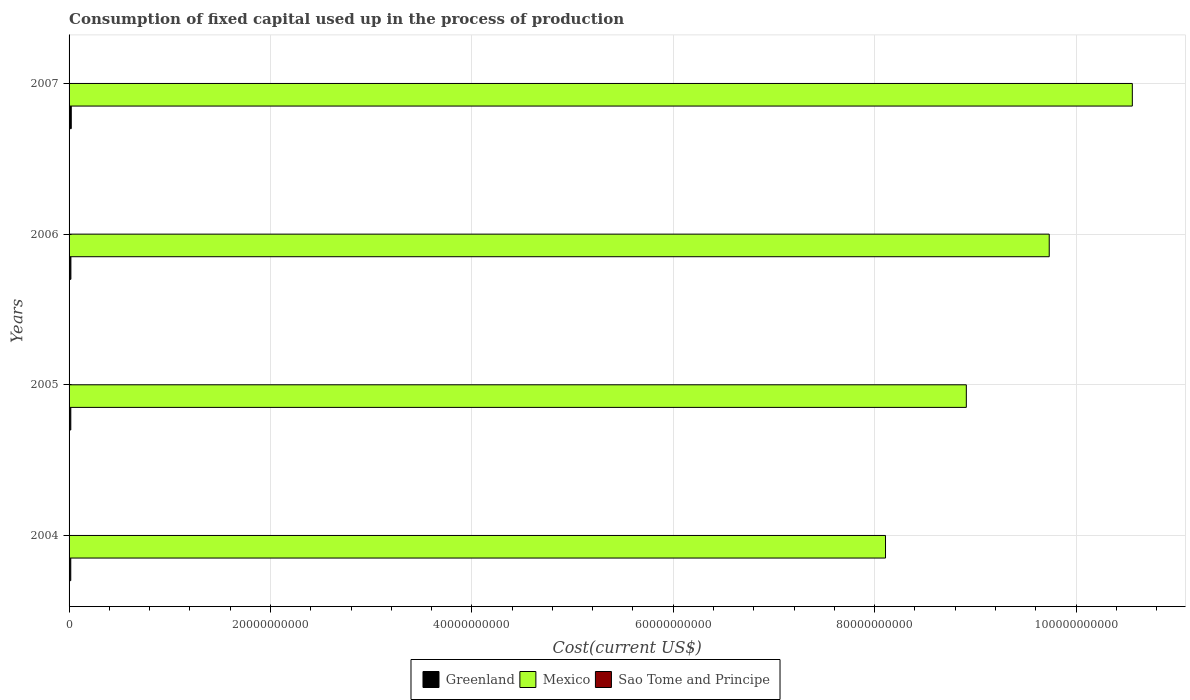How many bars are there on the 2nd tick from the bottom?
Offer a very short reply. 3. What is the amount consumed in the process of production in Sao Tome and Principe in 2004?
Your answer should be compact. 1.56e+07. Across all years, what is the maximum amount consumed in the process of production in Greenland?
Your answer should be compact. 2.18e+08. Across all years, what is the minimum amount consumed in the process of production in Mexico?
Provide a short and direct response. 8.11e+1. What is the total amount consumed in the process of production in Greenland in the graph?
Provide a short and direct response. 7.39e+08. What is the difference between the amount consumed in the process of production in Greenland in 2004 and that in 2005?
Your response must be concise. -3.38e+06. What is the difference between the amount consumed in the process of production in Sao Tome and Principe in 2006 and the amount consumed in the process of production in Mexico in 2007?
Give a very brief answer. -1.06e+11. What is the average amount consumed in the process of production in Greenland per year?
Your response must be concise. 1.85e+08. In the year 2007, what is the difference between the amount consumed in the process of production in Mexico and amount consumed in the process of production in Greenland?
Make the answer very short. 1.05e+11. What is the ratio of the amount consumed in the process of production in Mexico in 2004 to that in 2005?
Offer a terse response. 0.91. Is the amount consumed in the process of production in Mexico in 2004 less than that in 2006?
Your answer should be compact. Yes. Is the difference between the amount consumed in the process of production in Mexico in 2004 and 2005 greater than the difference between the amount consumed in the process of production in Greenland in 2004 and 2005?
Your answer should be very brief. No. What is the difference between the highest and the second highest amount consumed in the process of production in Greenland?
Your answer should be compact. 3.79e+07. What is the difference between the highest and the lowest amount consumed in the process of production in Greenland?
Give a very brief answer. 4.94e+07. What does the 3rd bar from the bottom in 2006 represents?
Your response must be concise. Sao Tome and Principe. Are all the bars in the graph horizontal?
Provide a succinct answer. Yes. What is the difference between two consecutive major ticks on the X-axis?
Give a very brief answer. 2.00e+1. Are the values on the major ticks of X-axis written in scientific E-notation?
Your response must be concise. No. Does the graph contain grids?
Provide a succinct answer. Yes. What is the title of the graph?
Ensure brevity in your answer.  Consumption of fixed capital used up in the process of production. What is the label or title of the X-axis?
Provide a succinct answer. Cost(current US$). What is the Cost(current US$) of Greenland in 2004?
Keep it short and to the point. 1.69e+08. What is the Cost(current US$) of Mexico in 2004?
Offer a very short reply. 8.11e+1. What is the Cost(current US$) in Sao Tome and Principe in 2004?
Make the answer very short. 1.56e+07. What is the Cost(current US$) in Greenland in 2005?
Provide a short and direct response. 1.72e+08. What is the Cost(current US$) in Mexico in 2005?
Your answer should be very brief. 8.91e+1. What is the Cost(current US$) of Sao Tome and Principe in 2005?
Your answer should be compact. 1.66e+07. What is the Cost(current US$) of Greenland in 2006?
Keep it short and to the point. 1.80e+08. What is the Cost(current US$) of Mexico in 2006?
Give a very brief answer. 9.73e+1. What is the Cost(current US$) of Sao Tome and Principe in 2006?
Ensure brevity in your answer.  1.69e+07. What is the Cost(current US$) in Greenland in 2007?
Provide a short and direct response. 2.18e+08. What is the Cost(current US$) in Mexico in 2007?
Keep it short and to the point. 1.06e+11. What is the Cost(current US$) in Sao Tome and Principe in 2007?
Give a very brief answer. 1.85e+07. Across all years, what is the maximum Cost(current US$) of Greenland?
Your answer should be compact. 2.18e+08. Across all years, what is the maximum Cost(current US$) in Mexico?
Provide a succinct answer. 1.06e+11. Across all years, what is the maximum Cost(current US$) in Sao Tome and Principe?
Give a very brief answer. 1.85e+07. Across all years, what is the minimum Cost(current US$) in Greenland?
Provide a succinct answer. 1.69e+08. Across all years, what is the minimum Cost(current US$) in Mexico?
Ensure brevity in your answer.  8.11e+1. Across all years, what is the minimum Cost(current US$) in Sao Tome and Principe?
Your answer should be very brief. 1.56e+07. What is the total Cost(current US$) in Greenland in the graph?
Provide a succinct answer. 7.39e+08. What is the total Cost(current US$) in Mexico in the graph?
Ensure brevity in your answer.  3.73e+11. What is the total Cost(current US$) of Sao Tome and Principe in the graph?
Offer a very short reply. 6.76e+07. What is the difference between the Cost(current US$) in Greenland in 2004 and that in 2005?
Your response must be concise. -3.38e+06. What is the difference between the Cost(current US$) in Mexico in 2004 and that in 2005?
Provide a short and direct response. -8.03e+09. What is the difference between the Cost(current US$) in Sao Tome and Principe in 2004 and that in 2005?
Make the answer very short. -1.04e+06. What is the difference between the Cost(current US$) of Greenland in 2004 and that in 2006?
Make the answer very short. -1.14e+07. What is the difference between the Cost(current US$) in Mexico in 2004 and that in 2006?
Your response must be concise. -1.63e+1. What is the difference between the Cost(current US$) of Sao Tome and Principe in 2004 and that in 2006?
Offer a very short reply. -1.29e+06. What is the difference between the Cost(current US$) in Greenland in 2004 and that in 2007?
Keep it short and to the point. -4.94e+07. What is the difference between the Cost(current US$) of Mexico in 2004 and that in 2007?
Ensure brevity in your answer.  -2.45e+1. What is the difference between the Cost(current US$) of Sao Tome and Principe in 2004 and that in 2007?
Your answer should be very brief. -2.95e+06. What is the difference between the Cost(current US$) in Greenland in 2005 and that in 2006?
Provide a succinct answer. -8.03e+06. What is the difference between the Cost(current US$) in Mexico in 2005 and that in 2006?
Ensure brevity in your answer.  -8.23e+09. What is the difference between the Cost(current US$) in Sao Tome and Principe in 2005 and that in 2006?
Your response must be concise. -2.56e+05. What is the difference between the Cost(current US$) of Greenland in 2005 and that in 2007?
Make the answer very short. -4.60e+07. What is the difference between the Cost(current US$) in Mexico in 2005 and that in 2007?
Your response must be concise. -1.65e+1. What is the difference between the Cost(current US$) of Sao Tome and Principe in 2005 and that in 2007?
Ensure brevity in your answer.  -1.92e+06. What is the difference between the Cost(current US$) of Greenland in 2006 and that in 2007?
Your answer should be compact. -3.79e+07. What is the difference between the Cost(current US$) of Mexico in 2006 and that in 2007?
Offer a very short reply. -8.25e+09. What is the difference between the Cost(current US$) in Sao Tome and Principe in 2006 and that in 2007?
Your answer should be compact. -1.66e+06. What is the difference between the Cost(current US$) in Greenland in 2004 and the Cost(current US$) in Mexico in 2005?
Provide a succinct answer. -8.89e+1. What is the difference between the Cost(current US$) in Greenland in 2004 and the Cost(current US$) in Sao Tome and Principe in 2005?
Make the answer very short. 1.52e+08. What is the difference between the Cost(current US$) in Mexico in 2004 and the Cost(current US$) in Sao Tome and Principe in 2005?
Your answer should be very brief. 8.11e+1. What is the difference between the Cost(current US$) in Greenland in 2004 and the Cost(current US$) in Mexico in 2006?
Give a very brief answer. -9.72e+1. What is the difference between the Cost(current US$) in Greenland in 2004 and the Cost(current US$) in Sao Tome and Principe in 2006?
Your answer should be compact. 1.52e+08. What is the difference between the Cost(current US$) of Mexico in 2004 and the Cost(current US$) of Sao Tome and Principe in 2006?
Offer a terse response. 8.11e+1. What is the difference between the Cost(current US$) of Greenland in 2004 and the Cost(current US$) of Mexico in 2007?
Provide a short and direct response. -1.05e+11. What is the difference between the Cost(current US$) in Greenland in 2004 and the Cost(current US$) in Sao Tome and Principe in 2007?
Offer a terse response. 1.50e+08. What is the difference between the Cost(current US$) in Mexico in 2004 and the Cost(current US$) in Sao Tome and Principe in 2007?
Offer a very short reply. 8.11e+1. What is the difference between the Cost(current US$) of Greenland in 2005 and the Cost(current US$) of Mexico in 2006?
Keep it short and to the point. -9.72e+1. What is the difference between the Cost(current US$) in Greenland in 2005 and the Cost(current US$) in Sao Tome and Principe in 2006?
Make the answer very short. 1.55e+08. What is the difference between the Cost(current US$) in Mexico in 2005 and the Cost(current US$) in Sao Tome and Principe in 2006?
Keep it short and to the point. 8.91e+1. What is the difference between the Cost(current US$) of Greenland in 2005 and the Cost(current US$) of Mexico in 2007?
Ensure brevity in your answer.  -1.05e+11. What is the difference between the Cost(current US$) of Greenland in 2005 and the Cost(current US$) of Sao Tome and Principe in 2007?
Keep it short and to the point. 1.53e+08. What is the difference between the Cost(current US$) in Mexico in 2005 and the Cost(current US$) in Sao Tome and Principe in 2007?
Offer a terse response. 8.91e+1. What is the difference between the Cost(current US$) of Greenland in 2006 and the Cost(current US$) of Mexico in 2007?
Give a very brief answer. -1.05e+11. What is the difference between the Cost(current US$) of Greenland in 2006 and the Cost(current US$) of Sao Tome and Principe in 2007?
Provide a succinct answer. 1.62e+08. What is the difference between the Cost(current US$) of Mexico in 2006 and the Cost(current US$) of Sao Tome and Principe in 2007?
Make the answer very short. 9.73e+1. What is the average Cost(current US$) of Greenland per year?
Your answer should be very brief. 1.85e+08. What is the average Cost(current US$) in Mexico per year?
Keep it short and to the point. 9.33e+1. What is the average Cost(current US$) of Sao Tome and Principe per year?
Ensure brevity in your answer.  1.69e+07. In the year 2004, what is the difference between the Cost(current US$) of Greenland and Cost(current US$) of Mexico?
Offer a terse response. -8.09e+1. In the year 2004, what is the difference between the Cost(current US$) of Greenland and Cost(current US$) of Sao Tome and Principe?
Your answer should be compact. 1.53e+08. In the year 2004, what is the difference between the Cost(current US$) of Mexico and Cost(current US$) of Sao Tome and Principe?
Provide a short and direct response. 8.11e+1. In the year 2005, what is the difference between the Cost(current US$) in Greenland and Cost(current US$) in Mexico?
Offer a terse response. -8.89e+1. In the year 2005, what is the difference between the Cost(current US$) of Greenland and Cost(current US$) of Sao Tome and Principe?
Your answer should be compact. 1.55e+08. In the year 2005, what is the difference between the Cost(current US$) in Mexico and Cost(current US$) in Sao Tome and Principe?
Make the answer very short. 8.91e+1. In the year 2006, what is the difference between the Cost(current US$) of Greenland and Cost(current US$) of Mexico?
Your answer should be compact. -9.72e+1. In the year 2006, what is the difference between the Cost(current US$) of Greenland and Cost(current US$) of Sao Tome and Principe?
Ensure brevity in your answer.  1.63e+08. In the year 2006, what is the difference between the Cost(current US$) in Mexico and Cost(current US$) in Sao Tome and Principe?
Keep it short and to the point. 9.73e+1. In the year 2007, what is the difference between the Cost(current US$) of Greenland and Cost(current US$) of Mexico?
Provide a short and direct response. -1.05e+11. In the year 2007, what is the difference between the Cost(current US$) in Greenland and Cost(current US$) in Sao Tome and Principe?
Offer a terse response. 1.99e+08. In the year 2007, what is the difference between the Cost(current US$) of Mexico and Cost(current US$) of Sao Tome and Principe?
Offer a terse response. 1.06e+11. What is the ratio of the Cost(current US$) of Greenland in 2004 to that in 2005?
Give a very brief answer. 0.98. What is the ratio of the Cost(current US$) in Mexico in 2004 to that in 2005?
Your response must be concise. 0.91. What is the ratio of the Cost(current US$) in Sao Tome and Principe in 2004 to that in 2005?
Offer a terse response. 0.94. What is the ratio of the Cost(current US$) of Greenland in 2004 to that in 2006?
Provide a short and direct response. 0.94. What is the ratio of the Cost(current US$) in Mexico in 2004 to that in 2006?
Offer a terse response. 0.83. What is the ratio of the Cost(current US$) in Sao Tome and Principe in 2004 to that in 2006?
Your answer should be very brief. 0.92. What is the ratio of the Cost(current US$) in Greenland in 2004 to that in 2007?
Keep it short and to the point. 0.77. What is the ratio of the Cost(current US$) in Mexico in 2004 to that in 2007?
Make the answer very short. 0.77. What is the ratio of the Cost(current US$) of Sao Tome and Principe in 2004 to that in 2007?
Offer a very short reply. 0.84. What is the ratio of the Cost(current US$) of Greenland in 2005 to that in 2006?
Offer a terse response. 0.96. What is the ratio of the Cost(current US$) in Mexico in 2005 to that in 2006?
Provide a short and direct response. 0.92. What is the ratio of the Cost(current US$) of Sao Tome and Principe in 2005 to that in 2006?
Keep it short and to the point. 0.98. What is the ratio of the Cost(current US$) in Greenland in 2005 to that in 2007?
Make the answer very short. 0.79. What is the ratio of the Cost(current US$) in Mexico in 2005 to that in 2007?
Keep it short and to the point. 0.84. What is the ratio of the Cost(current US$) of Sao Tome and Principe in 2005 to that in 2007?
Make the answer very short. 0.9. What is the ratio of the Cost(current US$) of Greenland in 2006 to that in 2007?
Make the answer very short. 0.83. What is the ratio of the Cost(current US$) of Mexico in 2006 to that in 2007?
Provide a succinct answer. 0.92. What is the ratio of the Cost(current US$) of Sao Tome and Principe in 2006 to that in 2007?
Provide a succinct answer. 0.91. What is the difference between the highest and the second highest Cost(current US$) of Greenland?
Offer a very short reply. 3.79e+07. What is the difference between the highest and the second highest Cost(current US$) in Mexico?
Give a very brief answer. 8.25e+09. What is the difference between the highest and the second highest Cost(current US$) in Sao Tome and Principe?
Your answer should be very brief. 1.66e+06. What is the difference between the highest and the lowest Cost(current US$) in Greenland?
Offer a terse response. 4.94e+07. What is the difference between the highest and the lowest Cost(current US$) of Mexico?
Offer a terse response. 2.45e+1. What is the difference between the highest and the lowest Cost(current US$) in Sao Tome and Principe?
Ensure brevity in your answer.  2.95e+06. 